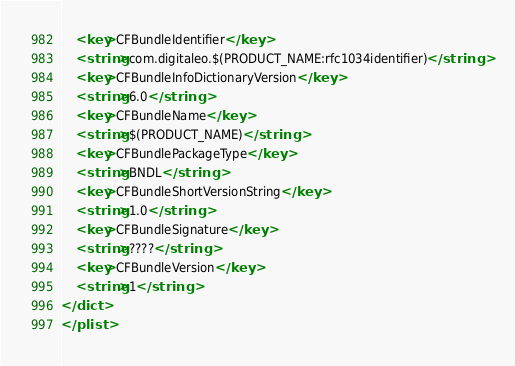Convert code to text. <code><loc_0><loc_0><loc_500><loc_500><_XML_>	<key>CFBundleIdentifier</key>
	<string>com.digitaleo.$(PRODUCT_NAME:rfc1034identifier)</string>
	<key>CFBundleInfoDictionaryVersion</key>
	<string>6.0</string>
	<key>CFBundleName</key>
	<string>$(PRODUCT_NAME)</string>
	<key>CFBundlePackageType</key>
	<string>BNDL</string>
	<key>CFBundleShortVersionString</key>
	<string>1.0</string>
	<key>CFBundleSignature</key>
	<string>????</string>
	<key>CFBundleVersion</key>
	<string>1</string>
</dict>
</plist>
</code> 